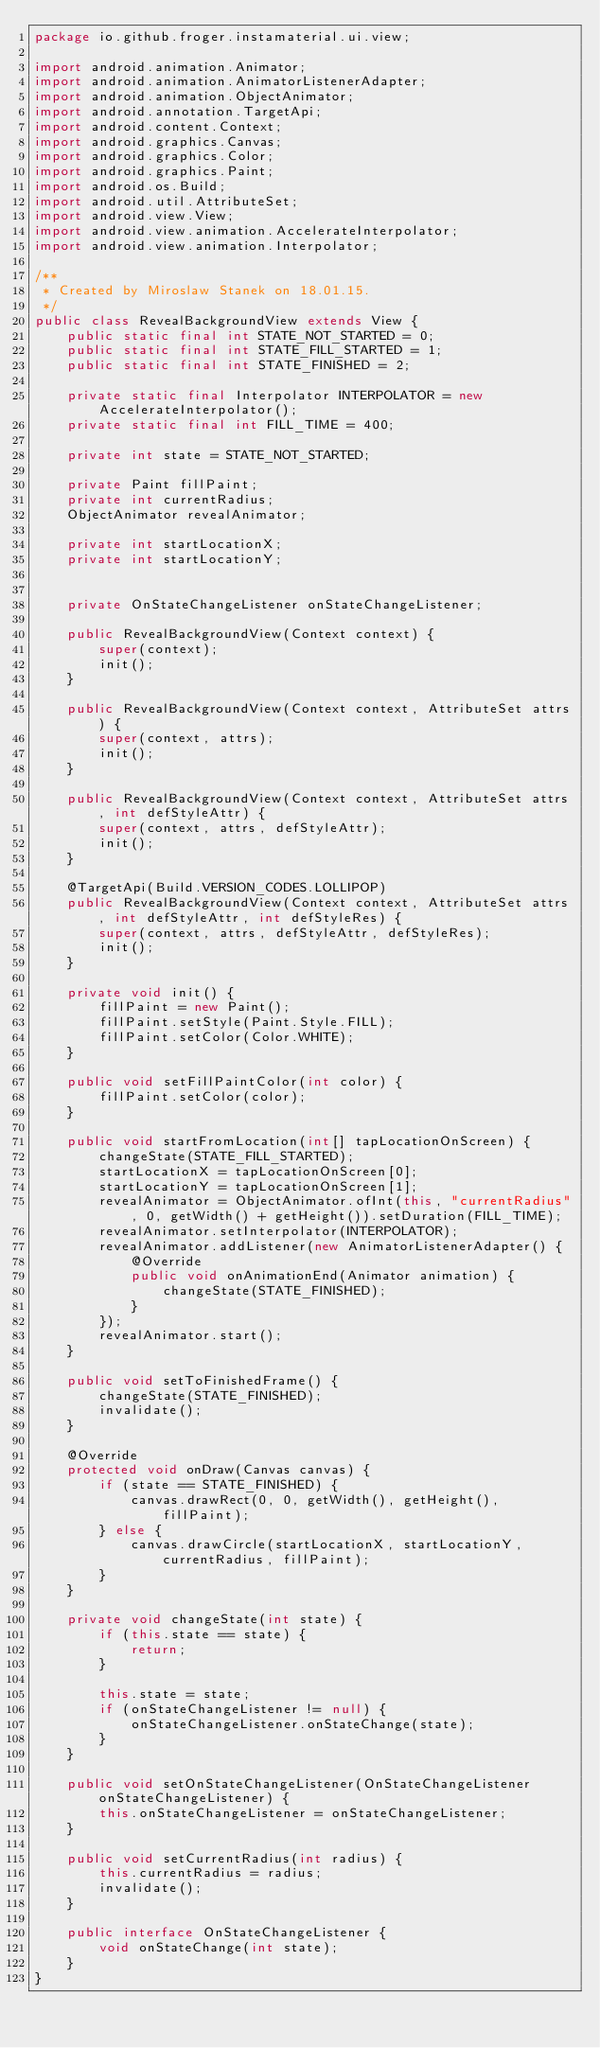<code> <loc_0><loc_0><loc_500><loc_500><_Java_>package io.github.froger.instamaterial.ui.view;

import android.animation.Animator;
import android.animation.AnimatorListenerAdapter;
import android.animation.ObjectAnimator;
import android.annotation.TargetApi;
import android.content.Context;
import android.graphics.Canvas;
import android.graphics.Color;
import android.graphics.Paint;
import android.os.Build;
import android.util.AttributeSet;
import android.view.View;
import android.view.animation.AccelerateInterpolator;
import android.view.animation.Interpolator;

/**
 * Created by Miroslaw Stanek on 18.01.15.
 */
public class RevealBackgroundView extends View {
    public static final int STATE_NOT_STARTED = 0;
    public static final int STATE_FILL_STARTED = 1;
    public static final int STATE_FINISHED = 2;

    private static final Interpolator INTERPOLATOR = new AccelerateInterpolator();
    private static final int FILL_TIME = 400;

    private int state = STATE_NOT_STARTED;

    private Paint fillPaint;
    private int currentRadius;
    ObjectAnimator revealAnimator;

    private int startLocationX;
    private int startLocationY;


    private OnStateChangeListener onStateChangeListener;

    public RevealBackgroundView(Context context) {
        super(context);
        init();
    }

    public RevealBackgroundView(Context context, AttributeSet attrs) {
        super(context, attrs);
        init();
    }

    public RevealBackgroundView(Context context, AttributeSet attrs, int defStyleAttr) {
        super(context, attrs, defStyleAttr);
        init();
    }

    @TargetApi(Build.VERSION_CODES.LOLLIPOP)
    public RevealBackgroundView(Context context, AttributeSet attrs, int defStyleAttr, int defStyleRes) {
        super(context, attrs, defStyleAttr, defStyleRes);
        init();
    }

    private void init() {
        fillPaint = new Paint();
        fillPaint.setStyle(Paint.Style.FILL);
        fillPaint.setColor(Color.WHITE);
    }

    public void setFillPaintColor(int color) {
        fillPaint.setColor(color);
    }

    public void startFromLocation(int[] tapLocationOnScreen) {
        changeState(STATE_FILL_STARTED);
        startLocationX = tapLocationOnScreen[0];
        startLocationY = tapLocationOnScreen[1];
        revealAnimator = ObjectAnimator.ofInt(this, "currentRadius", 0, getWidth() + getHeight()).setDuration(FILL_TIME);
        revealAnimator.setInterpolator(INTERPOLATOR);
        revealAnimator.addListener(new AnimatorListenerAdapter() {
            @Override
            public void onAnimationEnd(Animator animation) {
                changeState(STATE_FINISHED);
            }
        });
        revealAnimator.start();
    }

    public void setToFinishedFrame() {
        changeState(STATE_FINISHED);
        invalidate();
    }

    @Override
    protected void onDraw(Canvas canvas) {
        if (state == STATE_FINISHED) {
            canvas.drawRect(0, 0, getWidth(), getHeight(), fillPaint);
        } else {
            canvas.drawCircle(startLocationX, startLocationY, currentRadius, fillPaint);
        }
    }

    private void changeState(int state) {
        if (this.state == state) {
            return;
        }

        this.state = state;
        if (onStateChangeListener != null) {
            onStateChangeListener.onStateChange(state);
        }
    }

    public void setOnStateChangeListener(OnStateChangeListener onStateChangeListener) {
        this.onStateChangeListener = onStateChangeListener;
    }

    public void setCurrentRadius(int radius) {
        this.currentRadius = radius;
        invalidate();
    }

    public interface OnStateChangeListener {
        void onStateChange(int state);
    }
}
</code> 